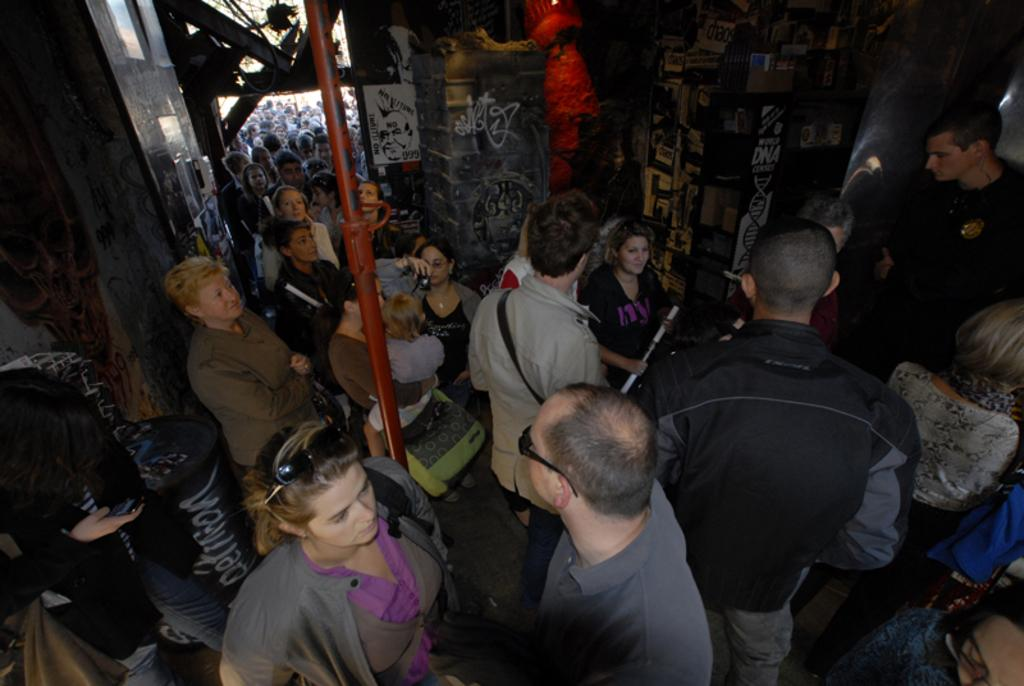What can be seen in the image related to a historical construction? There is a group of people in the historical construction, which has walls and pillars. There is also a pole inside the building. Are there any people outside the historical construction? Yes, there are people standing outside the building. Can you see a rose growing near the historical construction in the image? There is no rose visible in the image. 